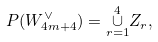<formula> <loc_0><loc_0><loc_500><loc_500>P ( W ^ { \vee } _ { 4 m + 4 } ) = \underset { r = 1 } { \overset { 4 } \cup } Z _ { r } ,</formula> 